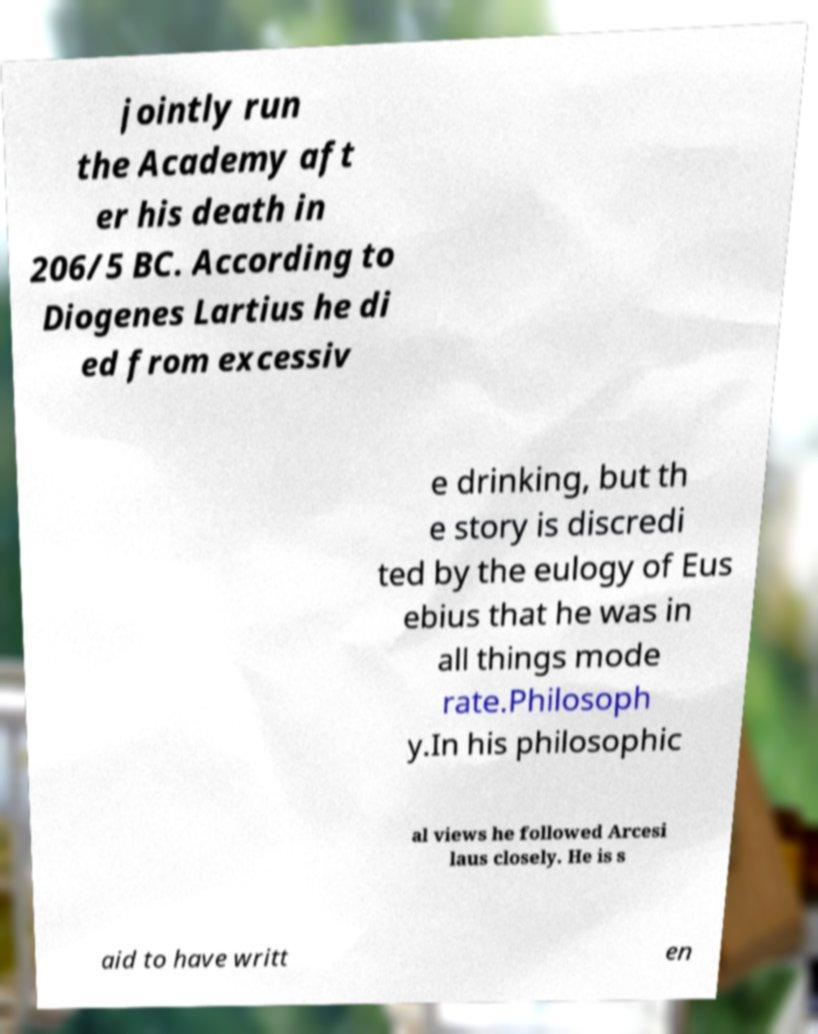Please identify and transcribe the text found in this image. jointly run the Academy aft er his death in 206/5 BC. According to Diogenes Lartius he di ed from excessiv e drinking, but th e story is discredi ted by the eulogy of Eus ebius that he was in all things mode rate.Philosoph y.In his philosophic al views he followed Arcesi laus closely. He is s aid to have writt en 